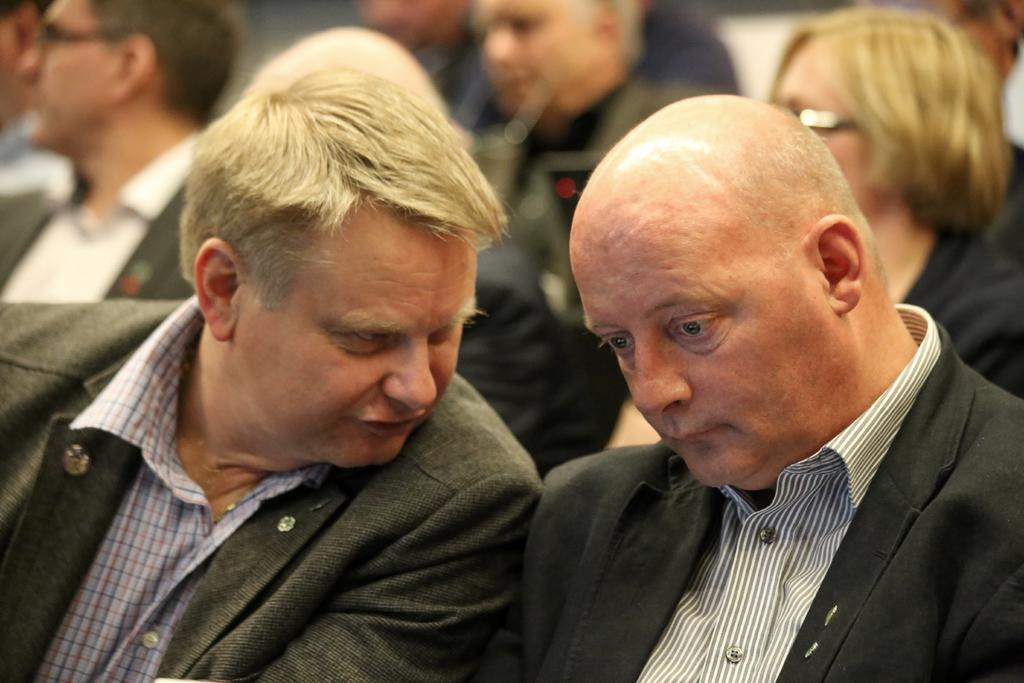How many people are in the center of the image? There are two persons in the center of the image. What can be observed about the appearance of the two persons? The two persons are wearing different costumes. Can you describe the people visible in the background of the image? There are people visible in the background of the image, but their specific characteristics are not mentioned in the provided facts. What type of clocks can be seen hanging on the wall in the image? There is no mention of clocks or walls in the provided facts, so it cannot be determined if any clocks are present in the image. 